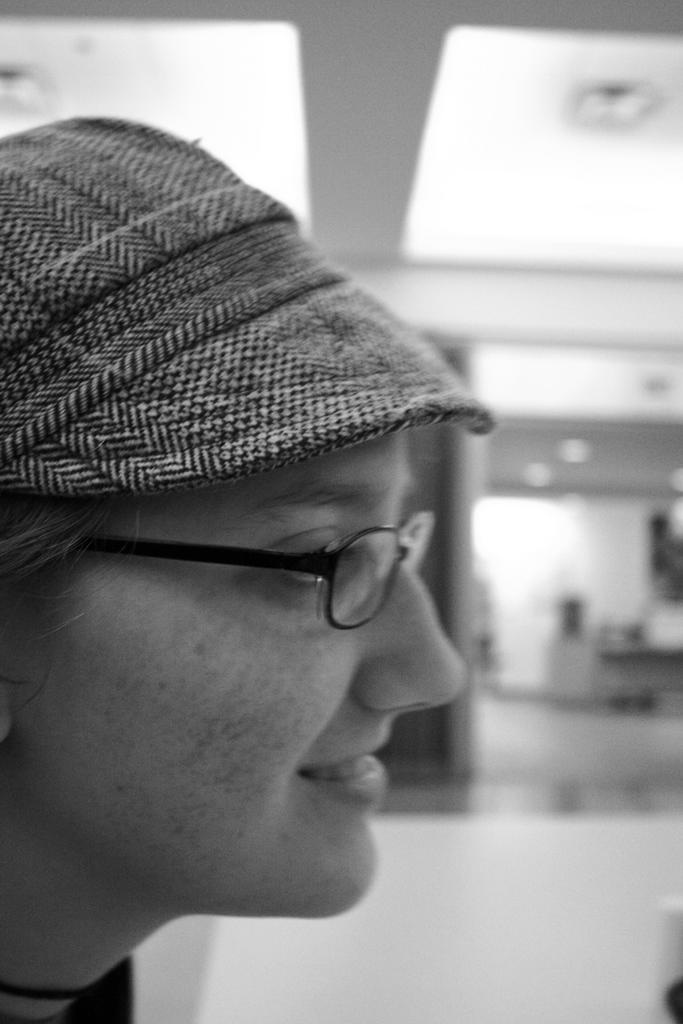In one or two sentences, can you explain what this image depicts? In this image there is a woman wearing a cap, spectacle visible on the left side, at top there is a roof, on the right side there is a floor visible. 